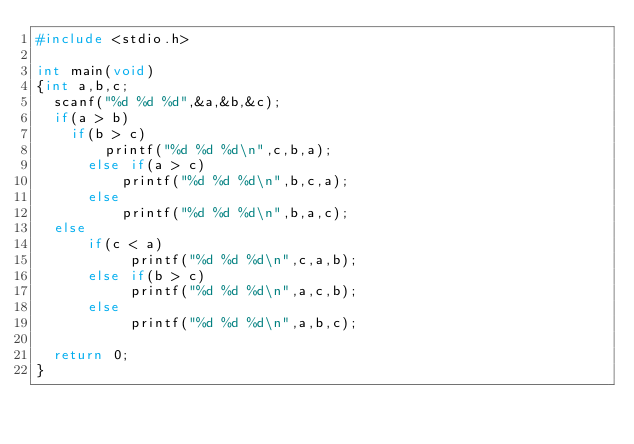<code> <loc_0><loc_0><loc_500><loc_500><_C_>#include <stdio.h>

int main(void)
{int a,b,c;
	scanf("%d %d %d",&a,&b,&c);
	if(a > b)
		if(b > c)
		    printf("%d %d %d\n",c,b,a);
	    else if(a > c)
	        printf("%d %d %d\n",b,c,a);
	    else 
	        printf("%d %d %d\n",b,a,c);
	else 
	    if(c < a)
	         printf("%d %d %d\n",c,a,b);
	    else if(b > c)
	         printf("%d %d %d\n",a,c,b);
	    else
	         printf("%d %d %d\n",a,b,c);
		
	return 0;
}</code> 